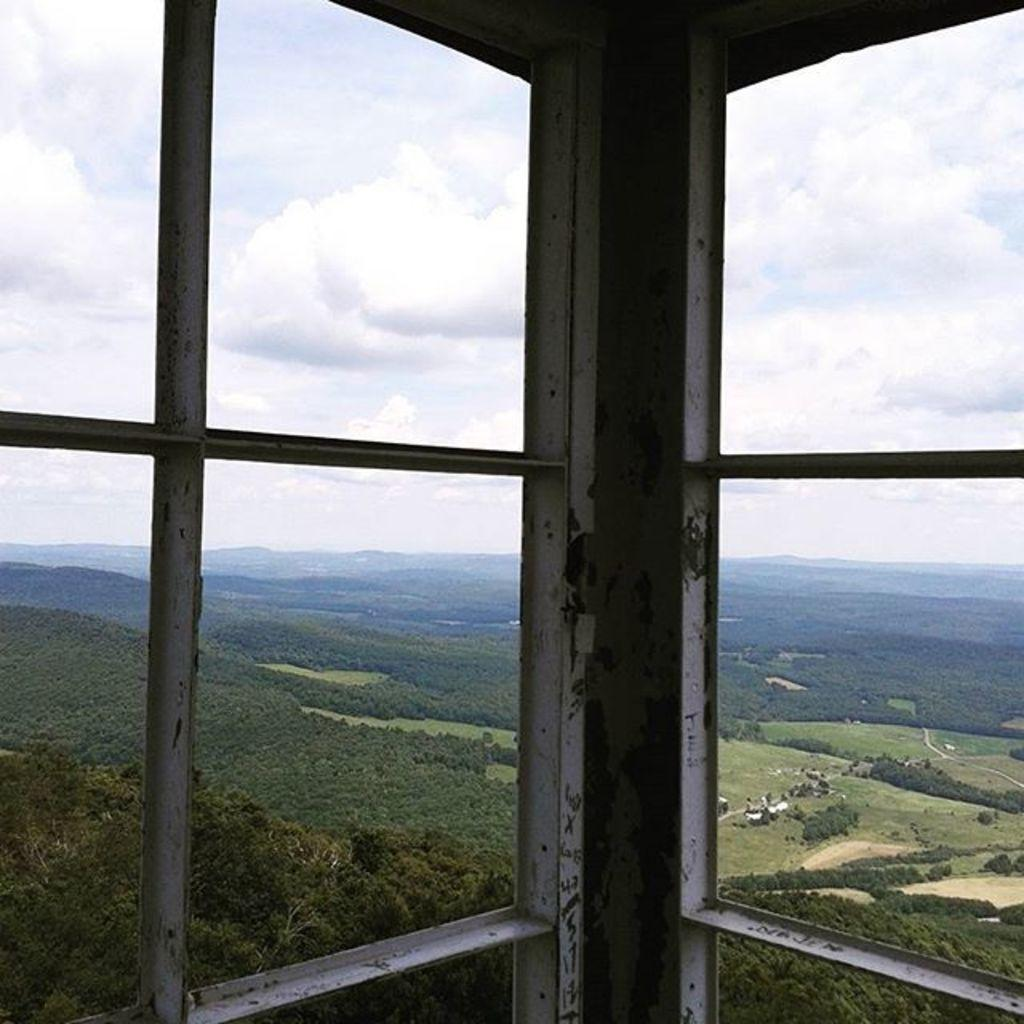What type of windows are visible in the image? The windows have iron rods in the image. What can be seen through the windows? Trees and hills are visible through the windows. What is visible in the background of the image? The sky is visible in the image. What can be observed in the sky? Clouds are present in the sky. What type of mine is visible in the image? There is no mine present in the image. How many people are sleeping in the image? There is no one sleeping in the image. 